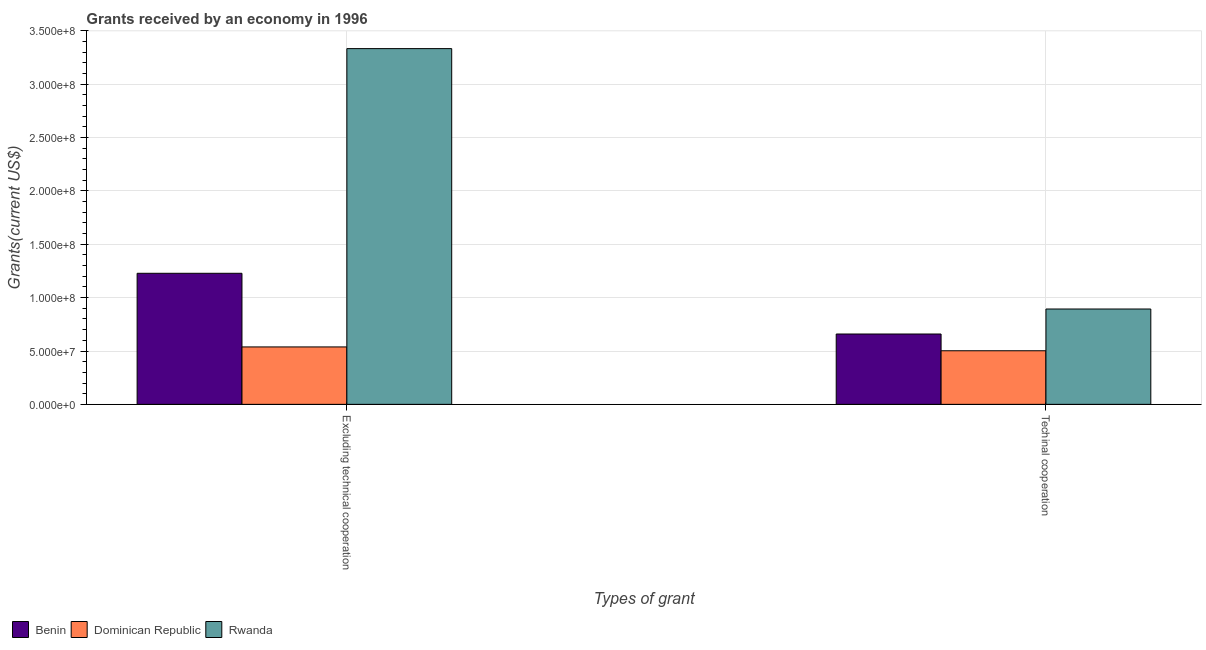How many different coloured bars are there?
Offer a very short reply. 3. How many bars are there on the 2nd tick from the left?
Keep it short and to the point. 3. What is the label of the 2nd group of bars from the left?
Provide a short and direct response. Techinal cooperation. What is the amount of grants received(excluding technical cooperation) in Benin?
Your response must be concise. 1.23e+08. Across all countries, what is the maximum amount of grants received(excluding technical cooperation)?
Make the answer very short. 3.33e+08. Across all countries, what is the minimum amount of grants received(excluding technical cooperation)?
Offer a terse response. 5.38e+07. In which country was the amount of grants received(excluding technical cooperation) maximum?
Ensure brevity in your answer.  Rwanda. In which country was the amount of grants received(including technical cooperation) minimum?
Your answer should be compact. Dominican Republic. What is the total amount of grants received(excluding technical cooperation) in the graph?
Provide a short and direct response. 5.10e+08. What is the difference between the amount of grants received(including technical cooperation) in Rwanda and that in Benin?
Ensure brevity in your answer.  2.34e+07. What is the difference between the amount of grants received(including technical cooperation) in Benin and the amount of grants received(excluding technical cooperation) in Rwanda?
Provide a succinct answer. -2.67e+08. What is the average amount of grants received(excluding technical cooperation) per country?
Provide a succinct answer. 1.70e+08. What is the difference between the amount of grants received(excluding technical cooperation) and amount of grants received(including technical cooperation) in Rwanda?
Your response must be concise. 2.44e+08. What is the ratio of the amount of grants received(excluding technical cooperation) in Dominican Republic to that in Benin?
Your response must be concise. 0.44. What does the 3rd bar from the left in Techinal cooperation represents?
Your answer should be very brief. Rwanda. What does the 3rd bar from the right in Excluding technical cooperation represents?
Provide a short and direct response. Benin. Are the values on the major ticks of Y-axis written in scientific E-notation?
Give a very brief answer. Yes. Does the graph contain grids?
Offer a terse response. Yes. Where does the legend appear in the graph?
Your answer should be very brief. Bottom left. What is the title of the graph?
Provide a short and direct response. Grants received by an economy in 1996. What is the label or title of the X-axis?
Keep it short and to the point. Types of grant. What is the label or title of the Y-axis?
Give a very brief answer. Grants(current US$). What is the Grants(current US$) of Benin in Excluding technical cooperation?
Provide a short and direct response. 1.23e+08. What is the Grants(current US$) in Dominican Republic in Excluding technical cooperation?
Offer a terse response. 5.38e+07. What is the Grants(current US$) in Rwanda in Excluding technical cooperation?
Ensure brevity in your answer.  3.33e+08. What is the Grants(current US$) in Benin in Techinal cooperation?
Keep it short and to the point. 6.59e+07. What is the Grants(current US$) in Dominican Republic in Techinal cooperation?
Ensure brevity in your answer.  5.02e+07. What is the Grants(current US$) in Rwanda in Techinal cooperation?
Make the answer very short. 8.94e+07. Across all Types of grant, what is the maximum Grants(current US$) in Benin?
Offer a very short reply. 1.23e+08. Across all Types of grant, what is the maximum Grants(current US$) of Dominican Republic?
Offer a terse response. 5.38e+07. Across all Types of grant, what is the maximum Grants(current US$) in Rwanda?
Keep it short and to the point. 3.33e+08. Across all Types of grant, what is the minimum Grants(current US$) in Benin?
Offer a terse response. 6.59e+07. Across all Types of grant, what is the minimum Grants(current US$) in Dominican Republic?
Keep it short and to the point. 5.02e+07. Across all Types of grant, what is the minimum Grants(current US$) in Rwanda?
Offer a very short reply. 8.94e+07. What is the total Grants(current US$) in Benin in the graph?
Provide a short and direct response. 1.89e+08. What is the total Grants(current US$) of Dominican Republic in the graph?
Your answer should be compact. 1.04e+08. What is the total Grants(current US$) of Rwanda in the graph?
Provide a succinct answer. 4.23e+08. What is the difference between the Grants(current US$) of Benin in Excluding technical cooperation and that in Techinal cooperation?
Your answer should be very brief. 5.69e+07. What is the difference between the Grants(current US$) in Dominican Republic in Excluding technical cooperation and that in Techinal cooperation?
Keep it short and to the point. 3.59e+06. What is the difference between the Grants(current US$) of Rwanda in Excluding technical cooperation and that in Techinal cooperation?
Offer a terse response. 2.44e+08. What is the difference between the Grants(current US$) of Benin in Excluding technical cooperation and the Grants(current US$) of Dominican Republic in Techinal cooperation?
Provide a succinct answer. 7.26e+07. What is the difference between the Grants(current US$) in Benin in Excluding technical cooperation and the Grants(current US$) in Rwanda in Techinal cooperation?
Offer a terse response. 3.35e+07. What is the difference between the Grants(current US$) of Dominican Republic in Excluding technical cooperation and the Grants(current US$) of Rwanda in Techinal cooperation?
Your response must be concise. -3.55e+07. What is the average Grants(current US$) in Benin per Types of grant?
Provide a succinct answer. 9.44e+07. What is the average Grants(current US$) in Dominican Republic per Types of grant?
Give a very brief answer. 5.20e+07. What is the average Grants(current US$) of Rwanda per Types of grant?
Provide a succinct answer. 2.11e+08. What is the difference between the Grants(current US$) of Benin and Grants(current US$) of Dominican Republic in Excluding technical cooperation?
Keep it short and to the point. 6.90e+07. What is the difference between the Grants(current US$) of Benin and Grants(current US$) of Rwanda in Excluding technical cooperation?
Provide a short and direct response. -2.11e+08. What is the difference between the Grants(current US$) of Dominican Republic and Grants(current US$) of Rwanda in Excluding technical cooperation?
Keep it short and to the point. -2.80e+08. What is the difference between the Grants(current US$) of Benin and Grants(current US$) of Dominican Republic in Techinal cooperation?
Offer a terse response. 1.57e+07. What is the difference between the Grants(current US$) of Benin and Grants(current US$) of Rwanda in Techinal cooperation?
Ensure brevity in your answer.  -2.34e+07. What is the difference between the Grants(current US$) of Dominican Republic and Grants(current US$) of Rwanda in Techinal cooperation?
Give a very brief answer. -3.91e+07. What is the ratio of the Grants(current US$) of Benin in Excluding technical cooperation to that in Techinal cooperation?
Offer a very short reply. 1.86. What is the ratio of the Grants(current US$) of Dominican Republic in Excluding technical cooperation to that in Techinal cooperation?
Provide a short and direct response. 1.07. What is the ratio of the Grants(current US$) of Rwanda in Excluding technical cooperation to that in Techinal cooperation?
Provide a succinct answer. 3.73. What is the difference between the highest and the second highest Grants(current US$) of Benin?
Make the answer very short. 5.69e+07. What is the difference between the highest and the second highest Grants(current US$) in Dominican Republic?
Provide a succinct answer. 3.59e+06. What is the difference between the highest and the second highest Grants(current US$) in Rwanda?
Give a very brief answer. 2.44e+08. What is the difference between the highest and the lowest Grants(current US$) in Benin?
Your answer should be very brief. 5.69e+07. What is the difference between the highest and the lowest Grants(current US$) of Dominican Republic?
Provide a succinct answer. 3.59e+06. What is the difference between the highest and the lowest Grants(current US$) in Rwanda?
Keep it short and to the point. 2.44e+08. 